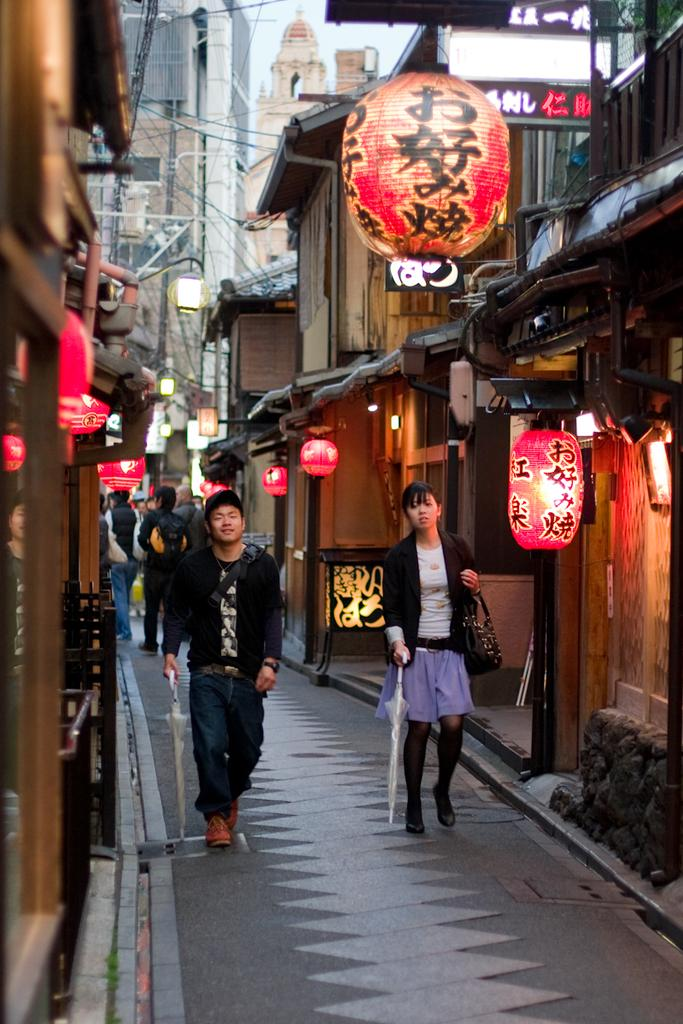What is the main feature in the center of the image? There is a road in the center of the image. What are the people in the image doing? There are people walking in the image. What can be seen on both sides of the road? There are houses with lights on both sides of the image. What is visible in the background of the image? There are buildings in the background of the image. What type of net can be seen hanging from the buildings in the image? There is no net visible in the image; only the road, people walking, houses with lights, and buildings in the background are present. 